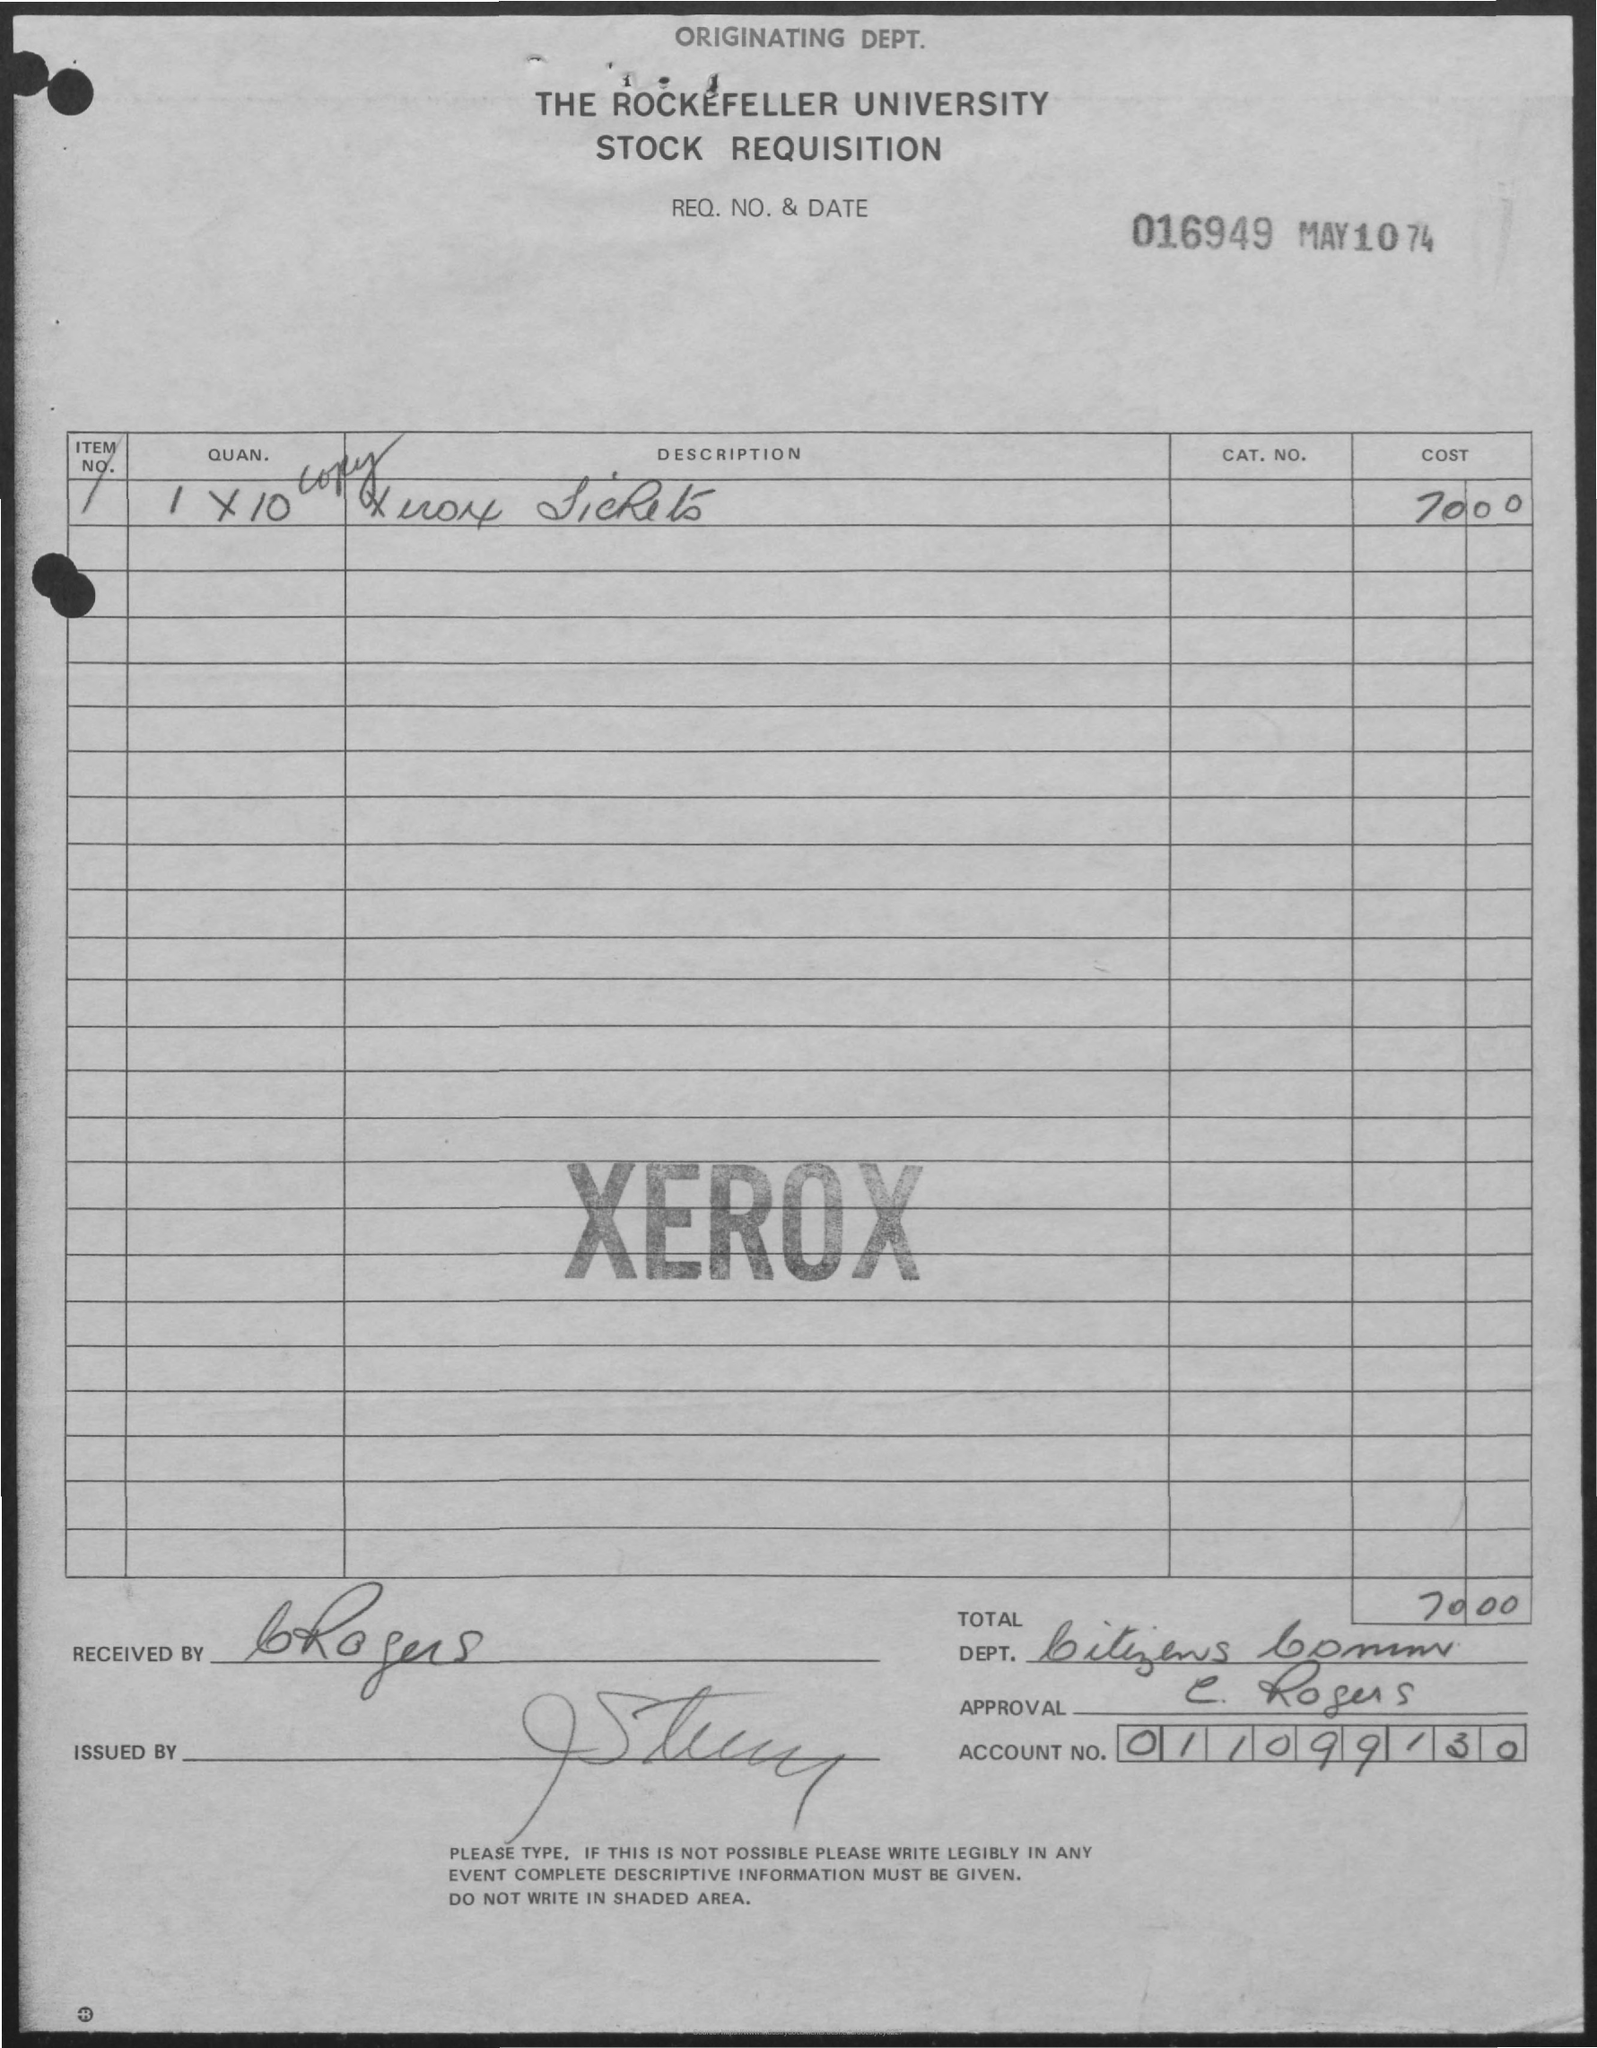What is the Req. No. & Date?
Your response must be concise. 016949 May 10 74. What is the first title in the document?
Your answer should be very brief. Originating dept. What is written in bold letters at the centre of this documents, which looks like a stamp?
Your answer should be compact. XEROX. What is the total?
Provide a short and direct response. 70 00. What is the Account Number?
Provide a short and direct response. 011099130. 